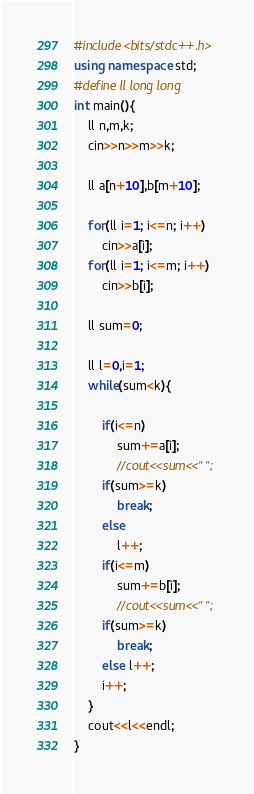<code> <loc_0><loc_0><loc_500><loc_500><_C++_>#include<bits/stdc++.h>
using namespace std;
#define ll long long
int main(){
    ll n,m,k;
    cin>>n>>m>>k;

    ll a[n+10],b[m+10];

    for(ll i=1; i<=n; i++)
        cin>>a[i];
    for(ll i=1; i<=m; i++)
        cin>>b[i];

    ll sum=0;

    ll l=0,i=1;
    while(sum<k){

        if(i<=n)
            sum+=a[i];
            //cout<<sum<<" ";
        if(sum>=k)
            break;
        else
            l++;
        if(i<=m)
            sum+=b[i];
            //cout<<sum<<" ";
        if(sum>=k)
            break;
        else l++;
        i++;
    }
    cout<<l<<endl;
}
</code> 